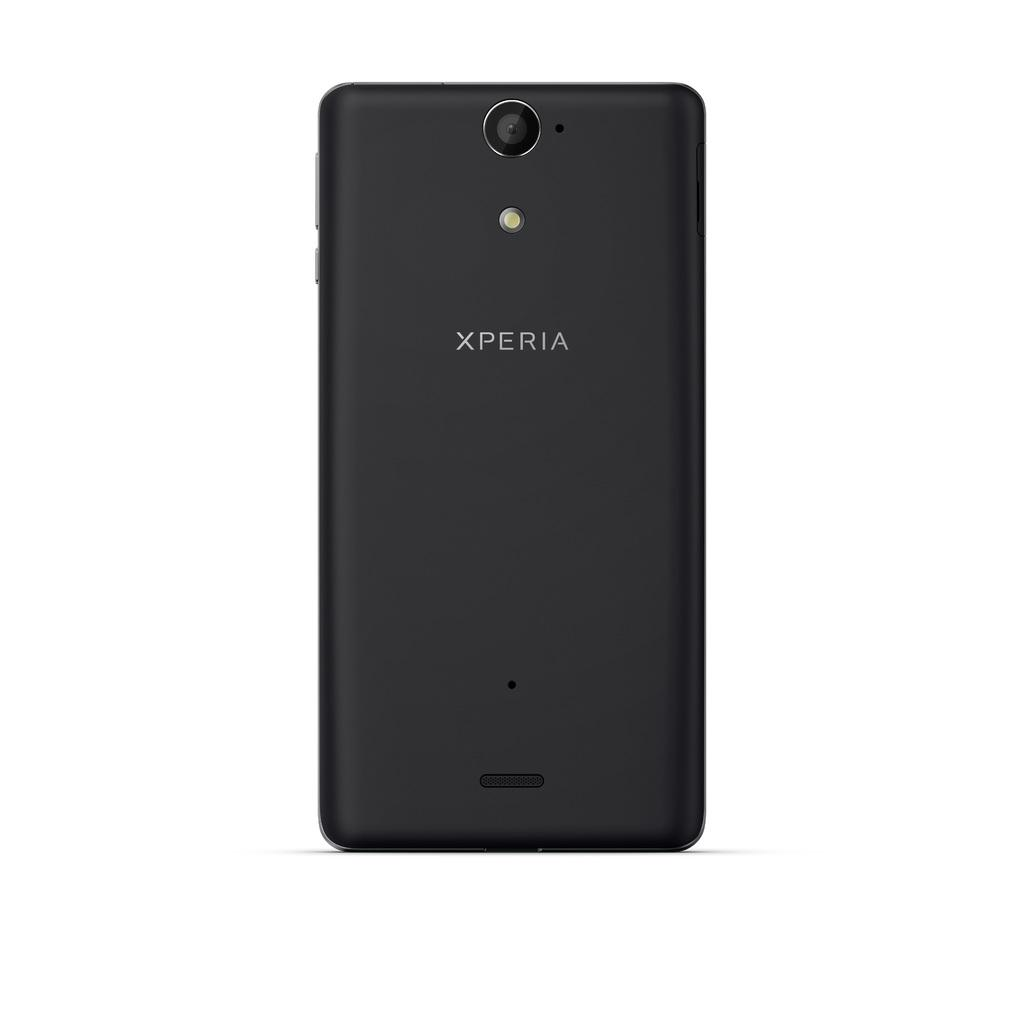Provide a one-sentence caption for the provided image. A black cellphone made by xperia is facing backward. 